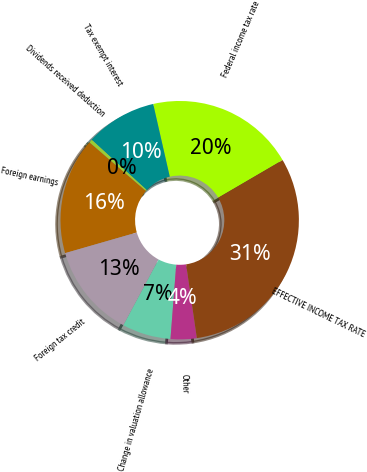<chart> <loc_0><loc_0><loc_500><loc_500><pie_chart><fcel>Federal income tax rate<fcel>Tax exempt interest<fcel>Dividends received deduction<fcel>Foreign earnings<fcel>Foreign tax credit<fcel>Change in valuation allowance<fcel>Other<fcel>EFFECTIVE INCOME TAX RATE<nl><fcel>20.16%<fcel>9.65%<fcel>0.46%<fcel>15.78%<fcel>12.72%<fcel>6.59%<fcel>3.53%<fcel>31.11%<nl></chart> 